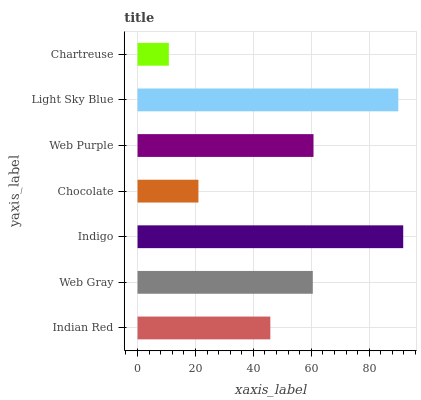Is Chartreuse the minimum?
Answer yes or no. Yes. Is Indigo the maximum?
Answer yes or no. Yes. Is Web Gray the minimum?
Answer yes or no. No. Is Web Gray the maximum?
Answer yes or no. No. Is Web Gray greater than Indian Red?
Answer yes or no. Yes. Is Indian Red less than Web Gray?
Answer yes or no. Yes. Is Indian Red greater than Web Gray?
Answer yes or no. No. Is Web Gray less than Indian Red?
Answer yes or no. No. Is Web Gray the high median?
Answer yes or no. Yes. Is Web Gray the low median?
Answer yes or no. Yes. Is Indian Red the high median?
Answer yes or no. No. Is Light Sky Blue the low median?
Answer yes or no. No. 